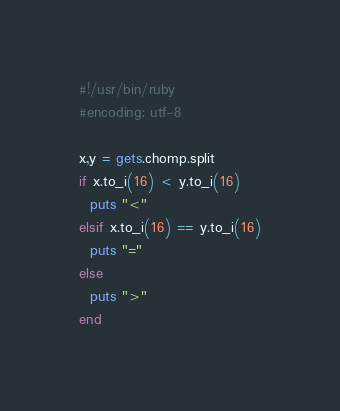<code> <loc_0><loc_0><loc_500><loc_500><_Ruby_>#!/usr/bin/ruby
#encoding: utf-8

x,y = gets.chomp.split
if x.to_i(16) < y.to_i(16)
  puts "<"
elsif x.to_i(16) == y.to_i(16)
  puts "="
else
  puts ">"
end
</code> 